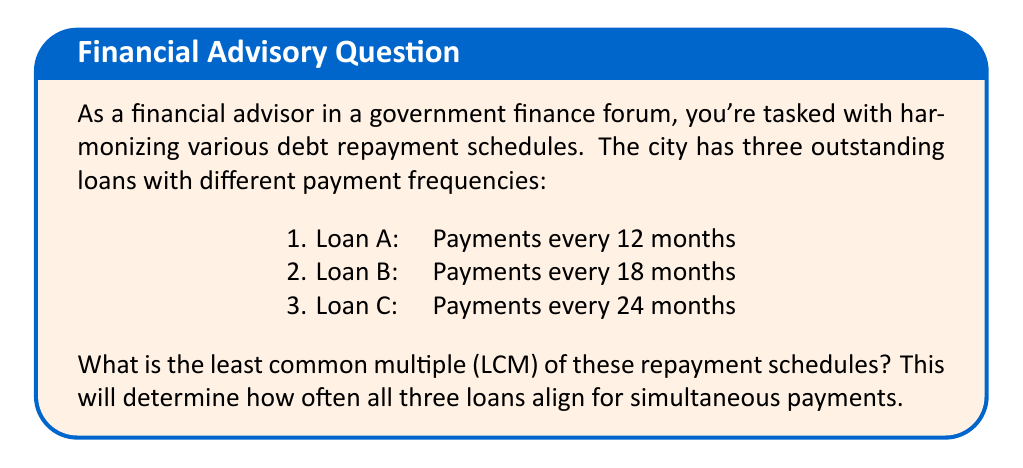Show me your answer to this math problem. To find the LCM of the repayment schedules, we'll follow these steps:

1) First, let's list out the prime factors of each number:
   12 = $2^2 \times 3$
   18 = $2 \times 3^2$
   24 = $2^3 \times 3$

2) The LCM will include the highest power of each prime factor from any of the numbers:
   - For 2, the highest power is 3 (from 24)
   - For 3, the highest power is 2 (from 18)

3) Therefore, the LCM will be:
   $LCM = 2^3 \times 3^2$

4) Let's calculate this:
   $LCM = 8 \times 9 = 72$

Thus, the repayment schedules will align every 72 months.
Answer: 72 months 